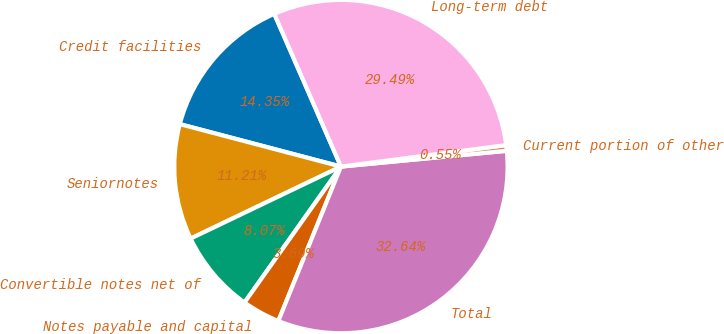Convert chart. <chart><loc_0><loc_0><loc_500><loc_500><pie_chart><fcel>Credit facilities<fcel>Seniornotes<fcel>Convertible notes net of<fcel>Notes payable and capital<fcel>Total<fcel>Current portion of other<fcel>Long-term debt<nl><fcel>14.35%<fcel>11.21%<fcel>8.07%<fcel>3.69%<fcel>32.64%<fcel>0.55%<fcel>29.49%<nl></chart> 